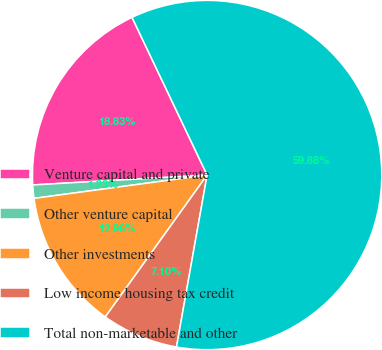Convert chart to OTSL. <chart><loc_0><loc_0><loc_500><loc_500><pie_chart><fcel>Venture capital and private<fcel>Other venture capital<fcel>Other investments<fcel>Low income housing tax credit<fcel>Total non-marketable and other<nl><fcel>18.83%<fcel>1.23%<fcel>12.96%<fcel>7.1%<fcel>59.88%<nl></chart> 